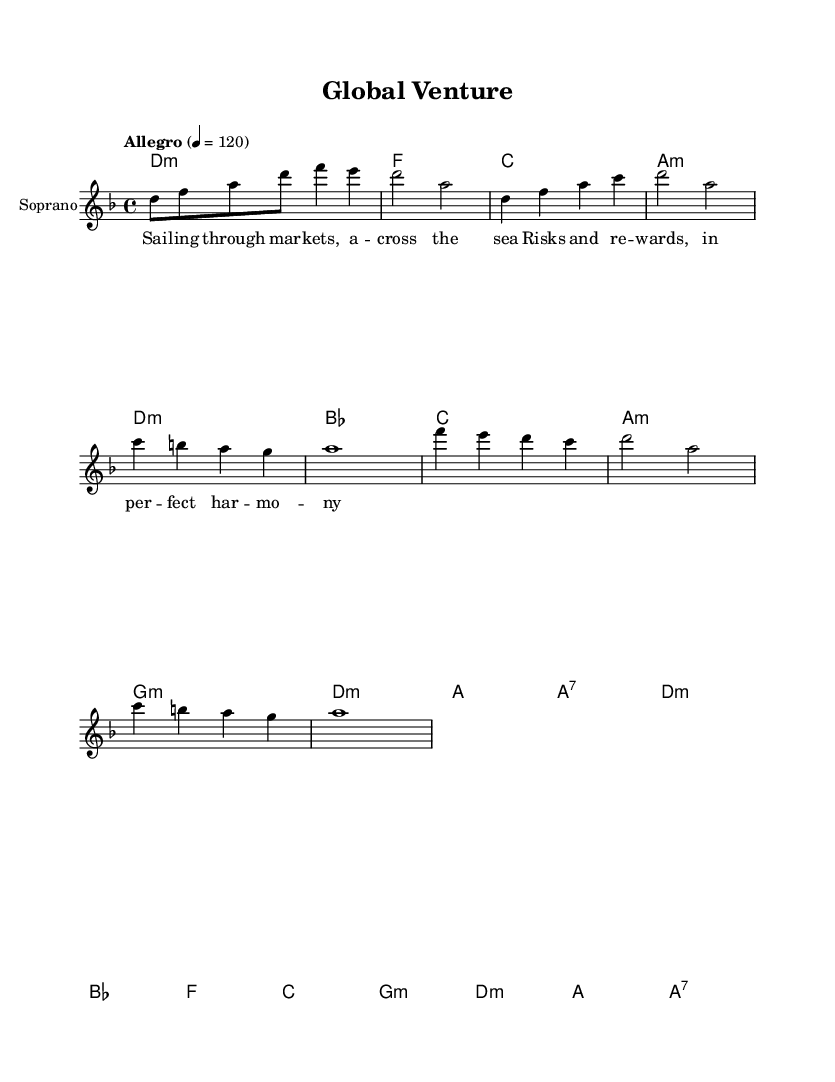What is the key signature of this music? The key signature is indicated at the beginning of the score, and it shows two flats which designate D minor (there are two flats: B♭ and E♭).
Answer: D minor What is the time signature of this piece? The time signature is presented right after the key signature. It shows a "4/4" signature, meaning there are four beats in each measure and a quarter note gets one beat.
Answer: 4/4 What is the tempo marking for this composition? The tempo marking is specified at the beginning of the score where it states "Allegro" indicating a fast, lively tempo, followed by "4 = 120" which shows the beats per minute.
Answer: Allegro How many measures are in the melody? By counting the melody's bar lines, we tally eight measures in total from the beginning to the final bar line in the melody.
Answer: Eight What type of harmony is predominantly used in the piece? Upon evaluating the chord changes listed, they include primarily minor chords like D minor and A minor, indicating that the piece leans towards a minor tonal harmony giving it a darker aspect typical in metal music.
Answer: Minor What thematic element is represented in the lyrics? The lyrics reflect on themes of global trade and international business relations, as seen in phrases like "sailing through markets" which metaphorically link sailing across the sea with navigating business ventures.
Answer: Global trade How do the lyrics and melody interact in terms of rhythm? Analyzing the lyrics against the melody, we observe that the syllables of the lyrics are aligned well with the rhythmic structure of the melody, creating a harmonious flow that enhances the lyrical meaning.
Answer: Rhythmic alignment 